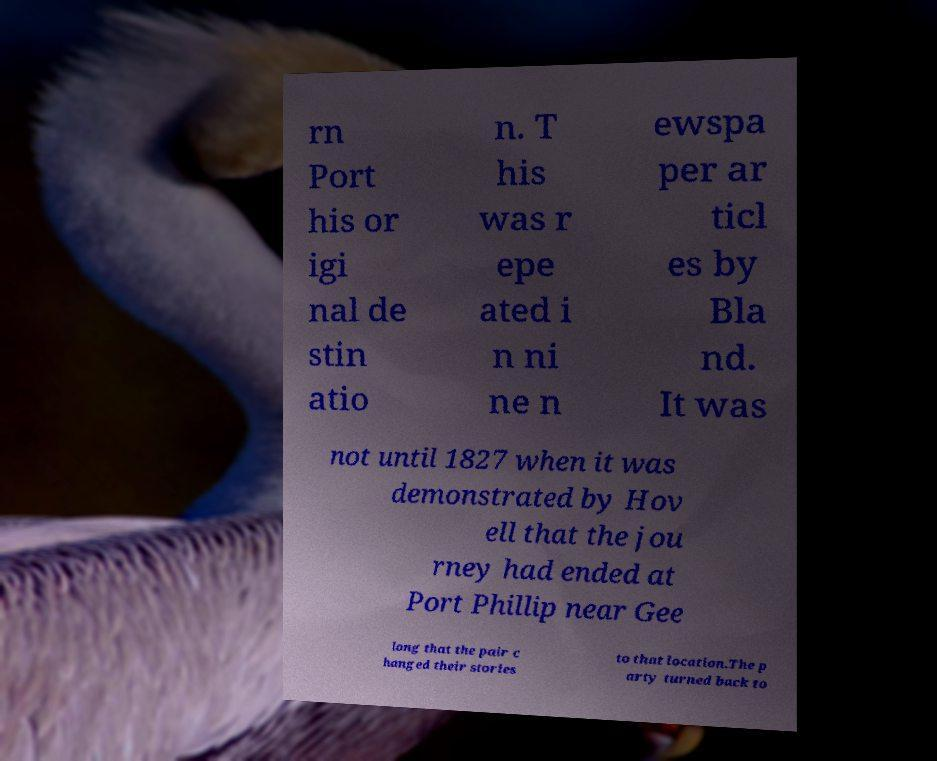Could you assist in decoding the text presented in this image and type it out clearly? rn Port his or igi nal de stin atio n. T his was r epe ated i n ni ne n ewspa per ar ticl es by Bla nd. It was not until 1827 when it was demonstrated by Hov ell that the jou rney had ended at Port Phillip near Gee long that the pair c hanged their stories to that location.The p arty turned back to 